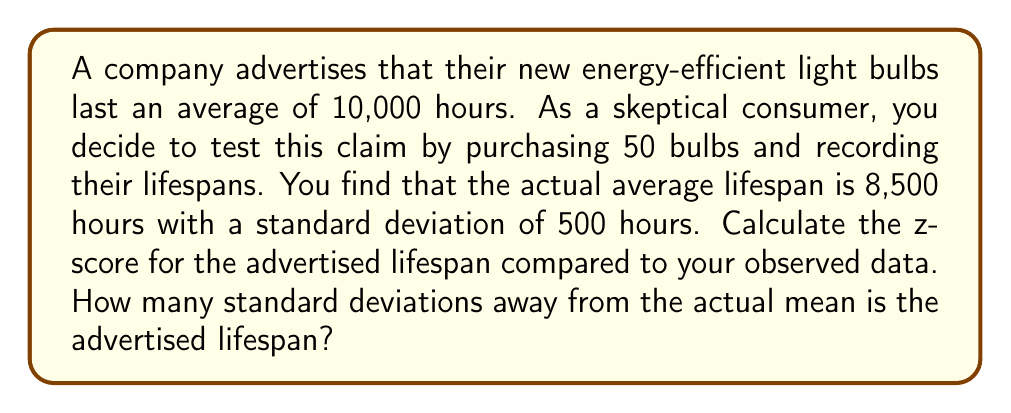Provide a solution to this math problem. To solve this problem, we'll use the z-score formula:

$$ z = \frac{x - \mu}{\sigma} $$

Where:
$x$ = advertised lifespan
$\mu$ = observed mean lifespan
$\sigma$ = standard deviation of observed lifespans

Step 1: Identify the values
$x = 10,000$ hours (advertised)
$\mu = 8,500$ hours (observed mean)
$\sigma = 500$ hours (observed standard deviation)

Step 2: Plug the values into the z-score formula
$$ z = \frac{10,000 - 8,500}{500} $$

Step 3: Simplify
$$ z = \frac{1,500}{500} = 3 $$

The z-score of 3 indicates that the advertised lifespan is 3 standard deviations above the observed mean, suggesting a significant discrepancy between the advertised and actual product performance.
Answer: 3 standard deviations 